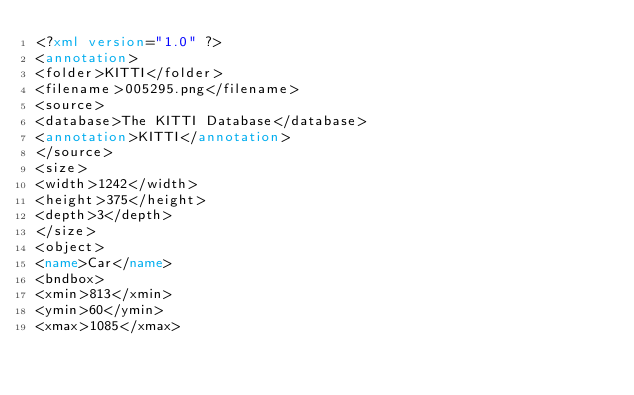Convert code to text. <code><loc_0><loc_0><loc_500><loc_500><_XML_><?xml version="1.0" ?>
<annotation>
<folder>KITTI</folder>
<filename>005295.png</filename>
<source>
<database>The KITTI Database</database>
<annotation>KITTI</annotation>
</source>
<size>
<width>1242</width>
<height>375</height>
<depth>3</depth>
</size>
<object>
<name>Car</name>
<bndbox>
<xmin>813</xmin>
<ymin>60</ymin>
<xmax>1085</xmax></code> 